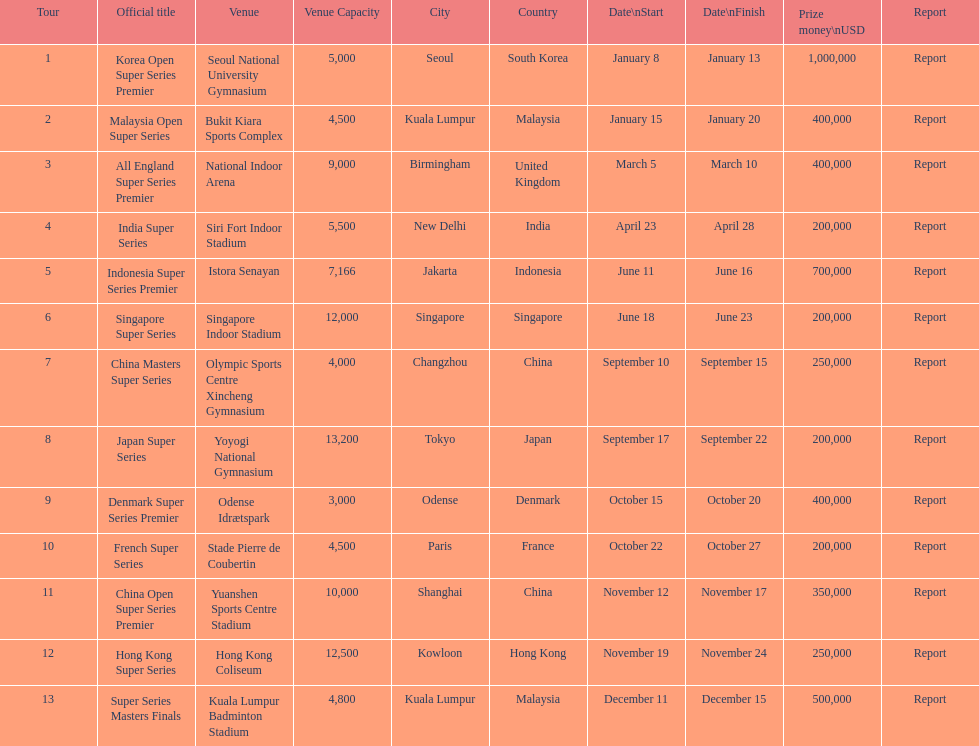How many tours took place during january? 2. 